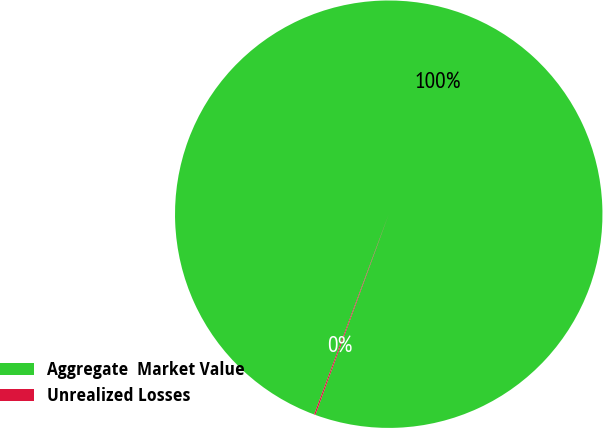<chart> <loc_0><loc_0><loc_500><loc_500><pie_chart><fcel>Aggregate  Market Value<fcel>Unrealized Losses<nl><fcel>99.9%<fcel>0.1%<nl></chart> 